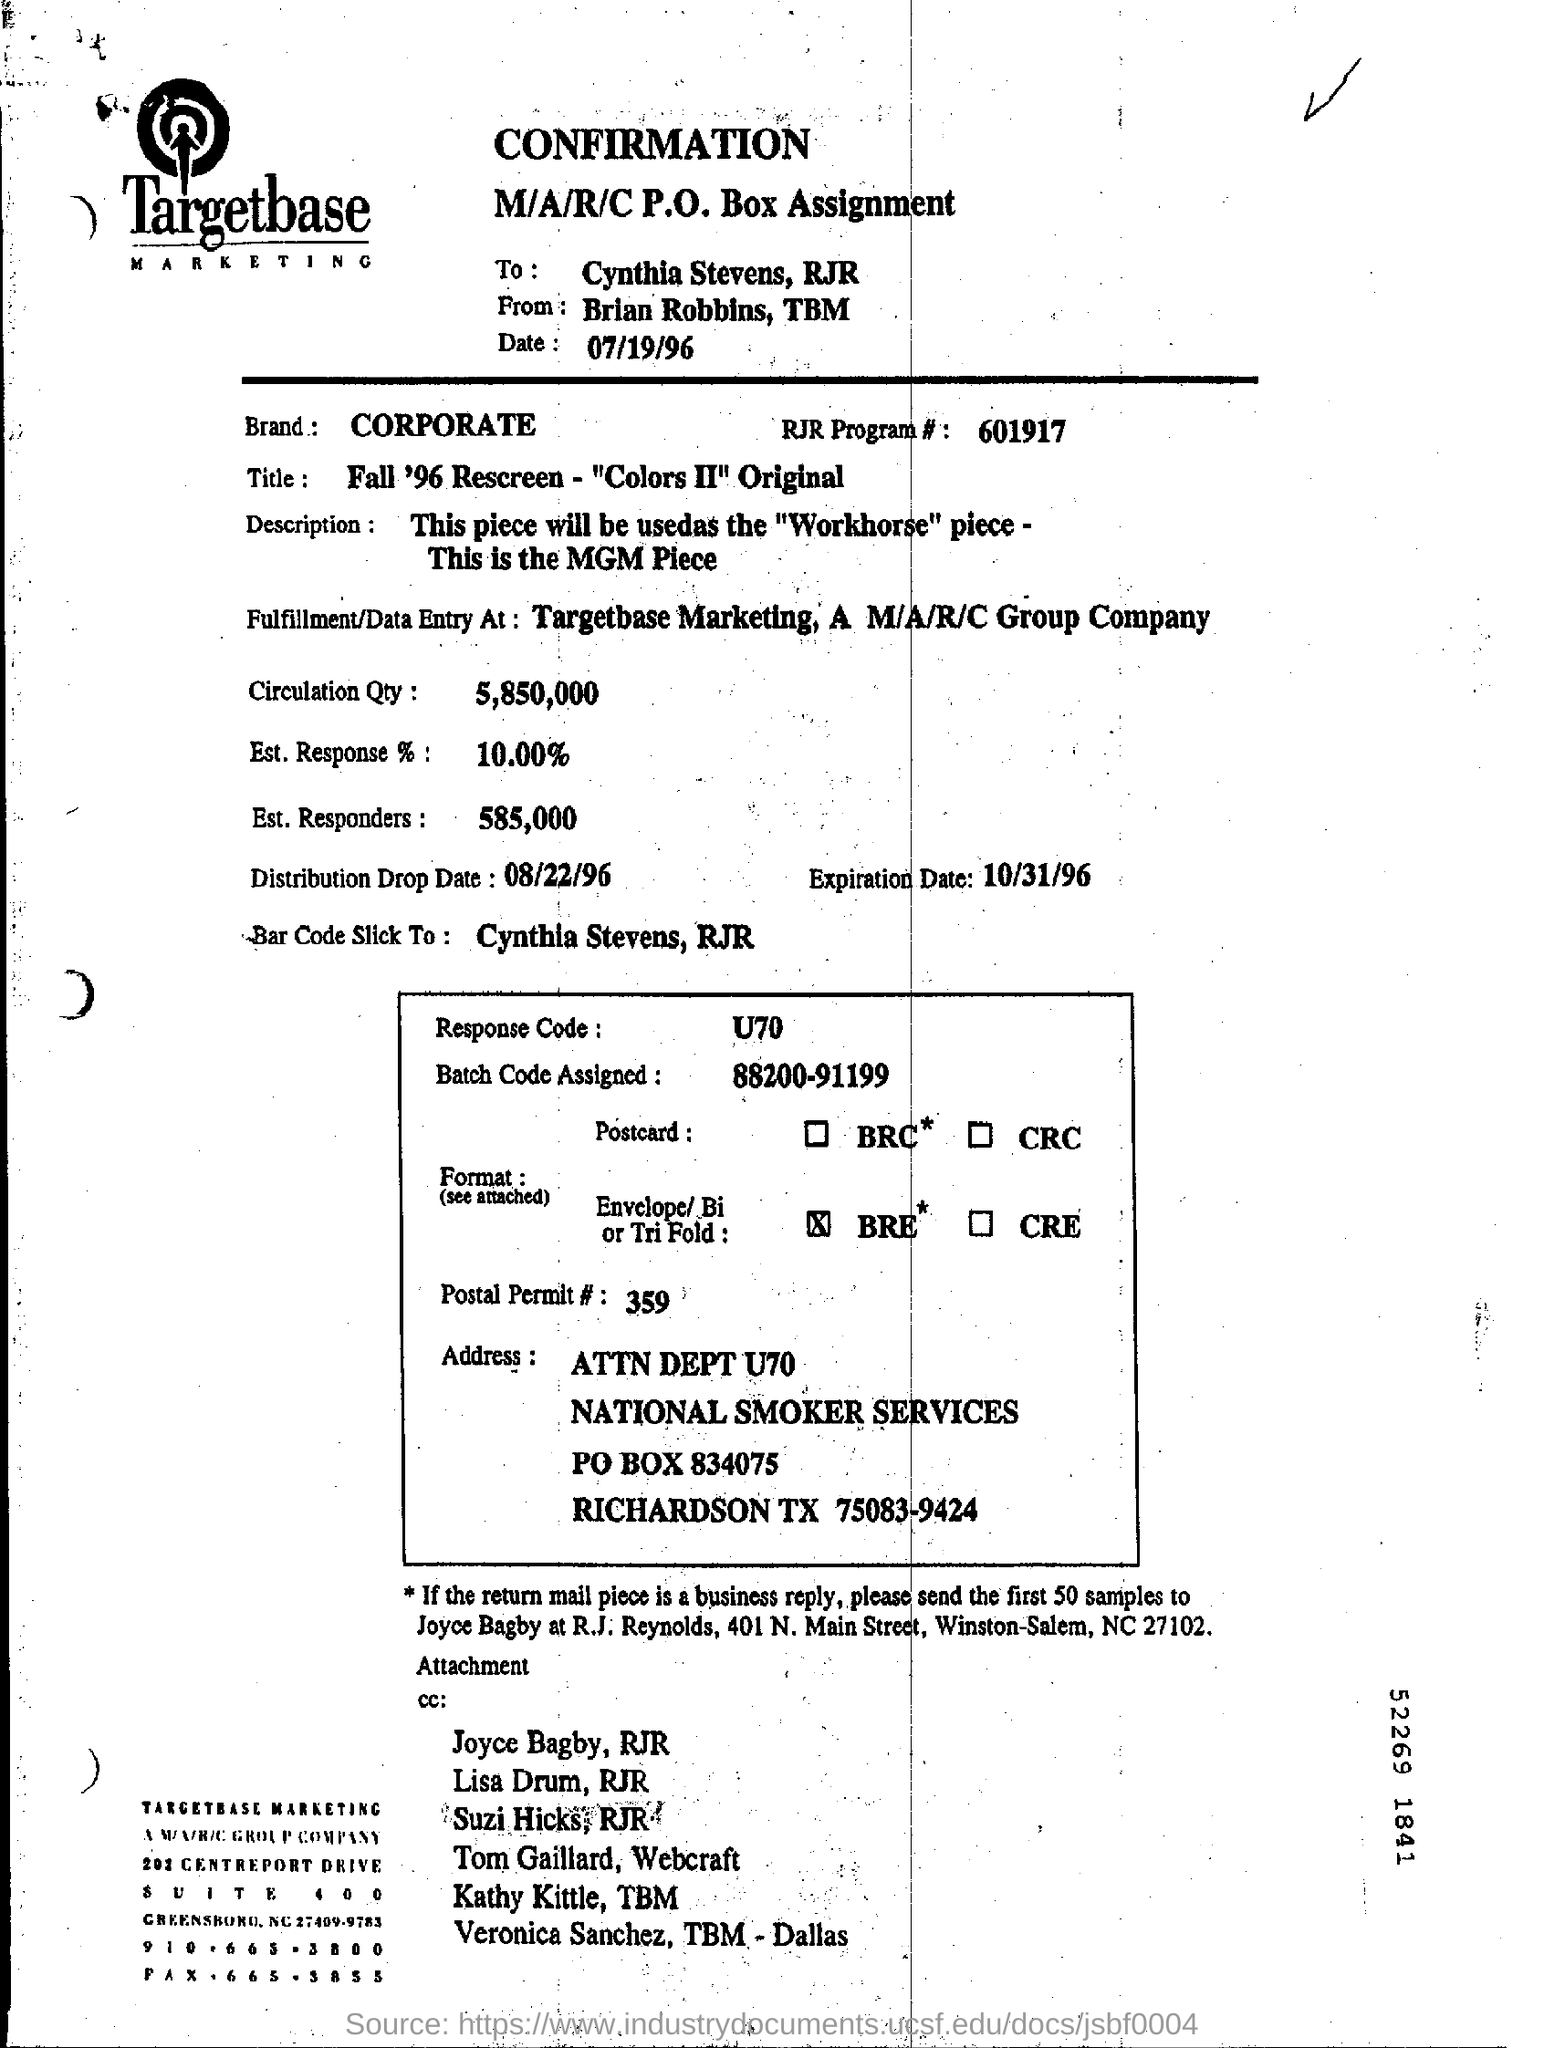How much is the Percentage of estimated response?
Your answer should be very brief. 10.00%. What is the response code?
Provide a succinct answer. U70. What is the post permit number?
Provide a succinct answer. 359. When is the confirmation dated?
Offer a terse response. 07/19/96. Where is the fulfillment or data entered?
Keep it short and to the point. Targetbase Marketing, A M/A/R/C Group Company. 